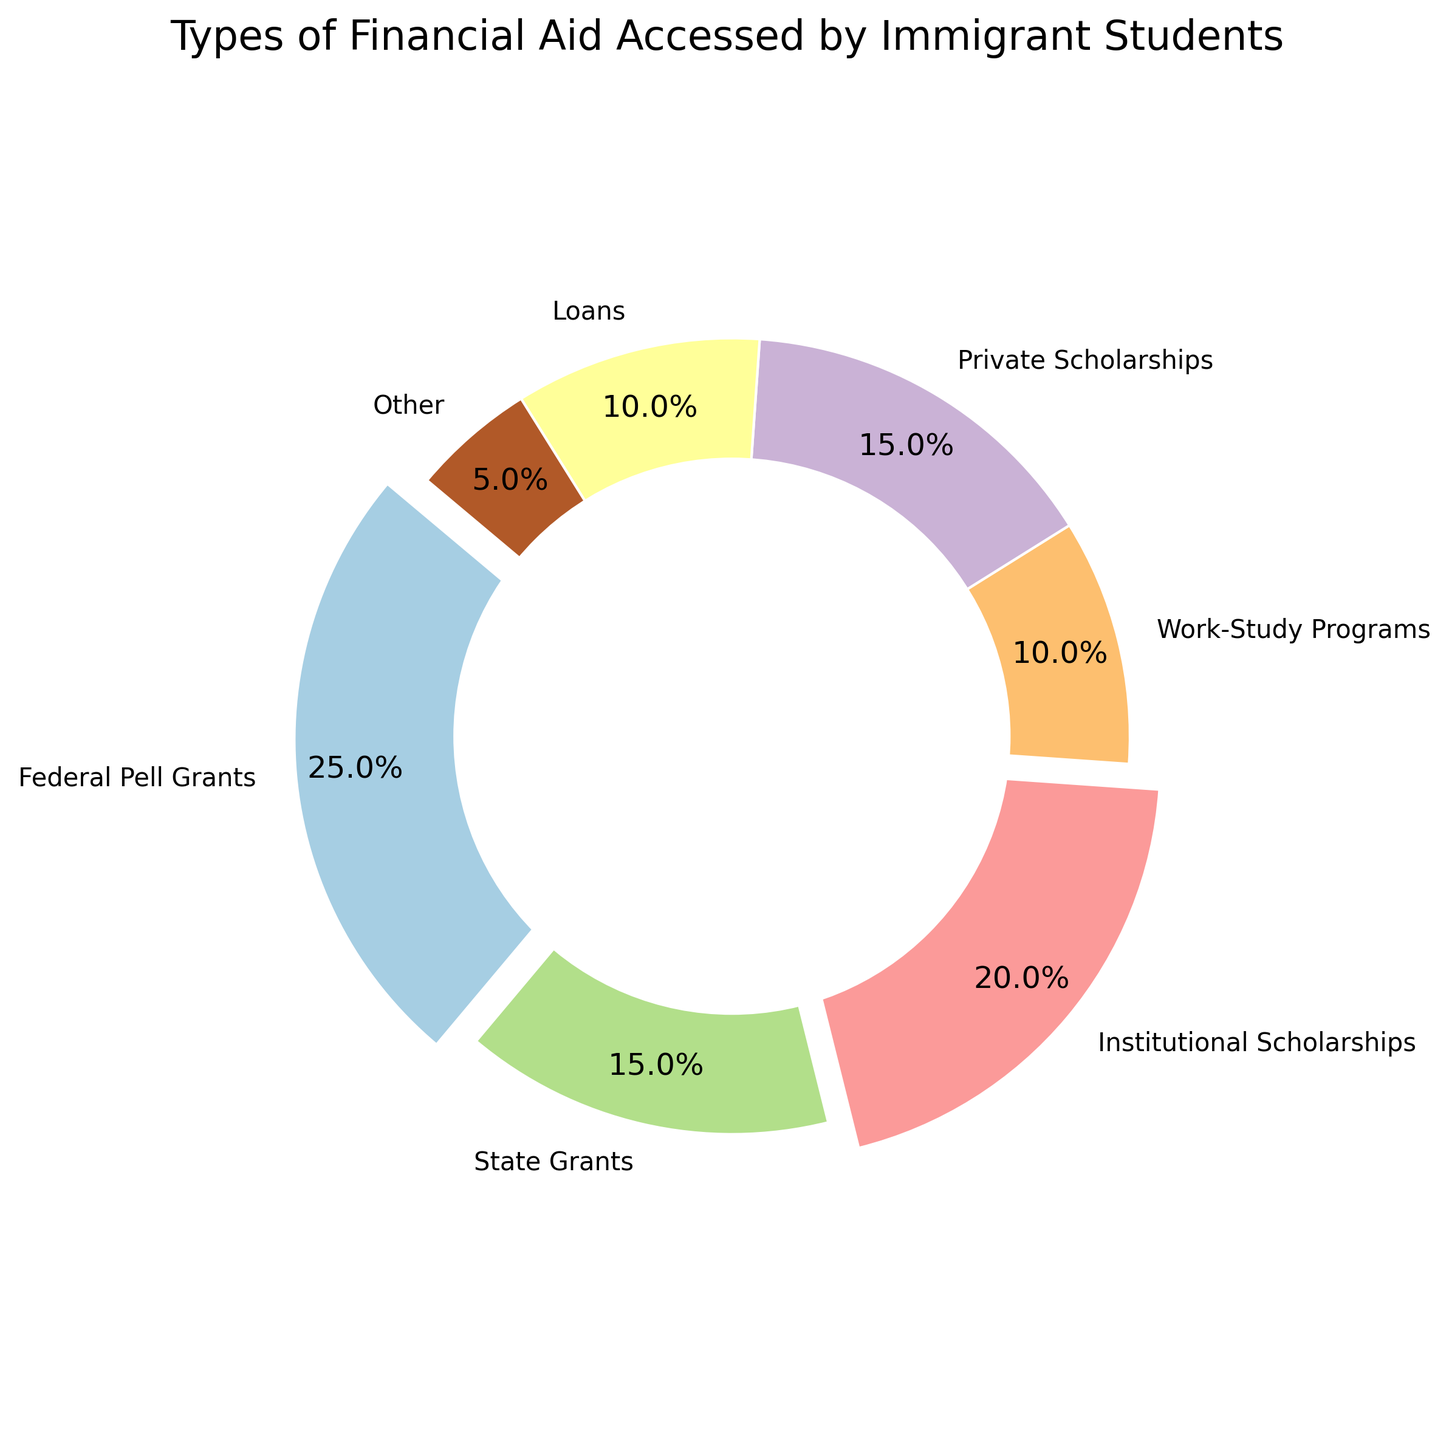Which financial aid type is the most accessed by immigrant students? The most accessed financial aid type will have the largest percentage in the pie chart. By examining the chart, we can see that "Federal Pell Grants" have the highest percentage at 25%.
Answer: Federal Pell Grants Which two types of financial aid have the same percentage access? By examining the pie chart, we can see that "State Grants" and "Private Scholarships" both have a percentage of 15%.
Answer: State Grants and Private Scholarships What's the total percentage of federal and state grants accessed? To find the total percentage of federal and state grants, sum their individual percentages. Federal Pell Grants are 25% and State Grants are 15%. So, 25% + 15% = 40%.
Answer: 40% How does the percentage of loans compare to work-study programs? By examining the chart, we see that both Loans and Work-Study Programs have the same percentage of 10%. Therefore, their percentages are equal.
Answer: Equal What is the visual characteristic that differentiates Federal Pell Grants from Loans in the pie chart? The Federal Pell Grants wedge is slightly exploded out from the pie chart, indicating it's a significant segment, whereas Loans are not exploded.
Answer: Explosion of wedge What is the percentage difference between institutional scholarships and work-study programs? Institutional Scholarships have a percentage of 20% and Work-Study Programs have 10%. Thus, the difference is 20% - 10% = 10%.
Answer: 10% If you sum the percentages of institutional scholarships, private scholarships, and loans, what would it be? Adding the percentages of Institutional Scholarships (20%), Private Scholarships (15%), and Loans (10%): 20% + 15% + 10% = 45%.
Answer: 45% What segment occupies the smallest part of the pie chart? By examining the pie chart, the segment labeled "Other" occupies the smallest part with 5%.
Answer: Other Which financial aid types together form exactly half of the pie chart? By finding a combination that sums up to 50%, we can see that "Federal Pell Grants" (25%) and "Institutional Scholarships" (20%) combined with "Other" (5%) form 25% + 20% + 5% = 50%.
Answer: Federal Pell Grants, Institutional Scholarships, and Other How much more prevalent are Federal Pell Grants compared to Loans? Federal Pell Grants are 25% whereas Loans are 10%, so the difference is 25% - 10% = 15%.
Answer: 15% 